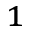Convert formula to latex. <formula><loc_0><loc_0><loc_500><loc_500>^ { 1 }</formula> 